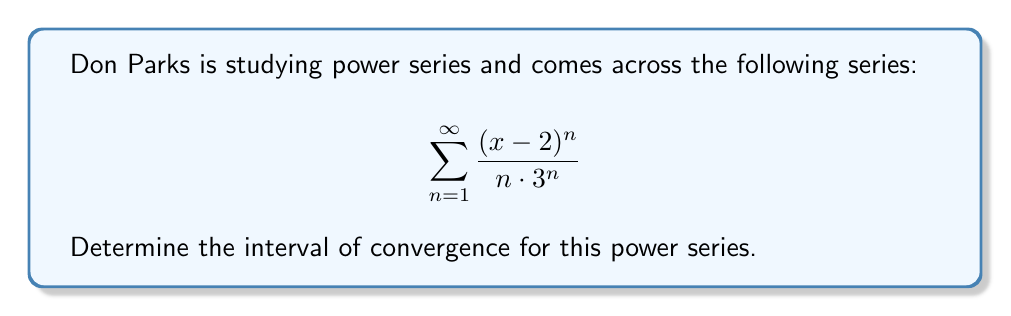Provide a solution to this math problem. To find the interval of convergence, we'll use the ratio test:

1) First, let's set up the ratio test:
   $$\lim_{n \to \infty} \left|\frac{a_{n+1}}{a_n}\right| = L$$
   where $a_n = \frac{(x-2)^n}{n\cdot 3^n}$

2) Calculate the ratio:
   $$\begin{align*}
   \left|\frac{a_{n+1}}{a_n}\right| &= \left|\frac{\frac{(x-2)^{n+1}}{(n+1)\cdot 3^{n+1}}}{\frac{(x-2)^n}{n\cdot 3^n}}\right| \\
   &= \left|\frac{(x-2)^{n+1}}{(n+1)\cdot 3^{n+1}} \cdot \frac{n\cdot 3^n}{(x-2)^n}\right| \\
   &= \left|\frac{n(x-2)}{(n+1)\cdot 3}\right|
   \end{align*}$$

3) Take the limit as $n$ approaches infinity:
   $$\lim_{n \to \infty} \left|\frac{n(x-2)}{(n+1)\cdot 3}\right| = \left|\frac{x-2}{3}\right|$$

4) For convergence, we need $\left|\frac{x-2}{3}\right| < 1$

5) Solve this inequality:
   $$-1 < \frac{x-2}{3} < 1$$
   $$-3 < x-2 < 3$$
   $$-1 < x < 5$$

6) Check the endpoints:
   At $x=-1$: $\sum_{n=1}^{\infty} \frac{(-3)^n}{n\cdot 3^n} = -\sum_{n=1}^{\infty} \frac{(-1)^n}{n}$, which is the alternating harmonic series (convergent).
   At $x=5$: $\sum_{n=1}^{\infty} \frac{3^n}{n\cdot 3^n} = \sum_{n=1}^{\infty} \frac{1}{n}$, which is the harmonic series (divergent).

Therefore, the interval of convergence is $[-1, 5)$.
Answer: $[-1, 5)$ 